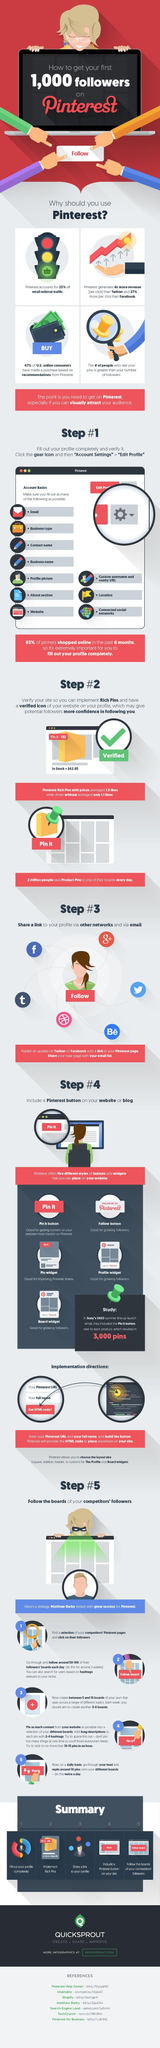What type of pinterest rich pins had more average likes?
Answer the question with a short phrase. with prices 